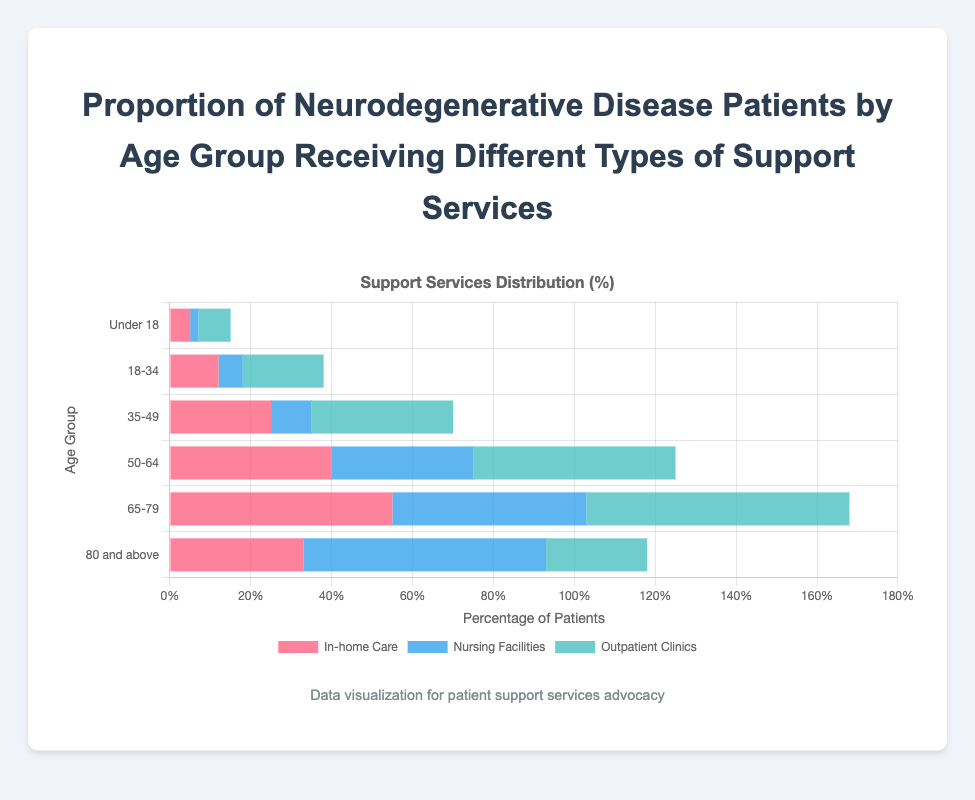What age group has the highest percentage of patients in outpatient clinics? Look at the blue bar representing outpatient clinic support for each age group. The age group 65-79 has the longest blue bar.
Answer: 65-79 For the 35-49 age group, how many more patients receive in-home care compared to nursing facilities? Subtract the value for nursing facilities from the value for in-home care in the 35-49 age group: 25 (in-home care) - 10 (nursing facilities) = 15.
Answer: 15 Which type of support service is most common among patients aged 50-64? Compare the lengths of the bars for in-home care, nursing facilities, and outpatient clinics in the 50-64 age group. The longest bar is outpatient clinics.
Answer: Outpatient clinics What's the total percentage of patients receiving in-home care across all age groups? Sum the values for in-home care across all age groups: 5 + 12 + 25 + 40 + 55 + 33 = 170.
Answer: 170 Is the percentage of patients aged under 18 receiving outpatient clinic support higher or lower than those in nursing facilities? Compare the lengths of the blue and green bars in the age group under 18. The blue bar (outpatient clinics) is longer than the green bar (nursing facilities).
Answer: Higher In the age group 80 and above, which support service is the least common? Look at the three bar lengths in the 80 and above age group and identify the shortest one. The shortest bar is outpatient clinics.
Answer: Outpatient clinics How does the percentage of patients receiving in-home care change from the age group 18-34 to the age group 35-49? Subtract the percentage of in-home care in the age group 18-34 from the age group 35-49: 25 (35-49) - 12 (18-34) = 13.
Answer: Increases by 13 What is the combined percentage of patients aged 65-79 receiving either nursing facilities or outpatient clinic services? Sum the percentages for nursing facilities and outpatient clinics in the age group 65-79: 48 + 65 = 113.
Answer: 113 Compare the proportion of patients using in-home care in the age group 50-64 with the age group 80 and above. Which is higher? Compare the values for in-home care in the age groups 50-64 (40) and 80 and above (33). The percentage is higher for 50-64.
Answer: 50-64 Which age group has the closest percentage of patients receiving nursing facilities and outpatient clinics? Compare the values for nursing facilities and outpatient clinics across all age groups. For the age group 18-34, nursing facilities are 6, and outpatient clinics are 20, which is closest among all groups.
Answer: 18-34 